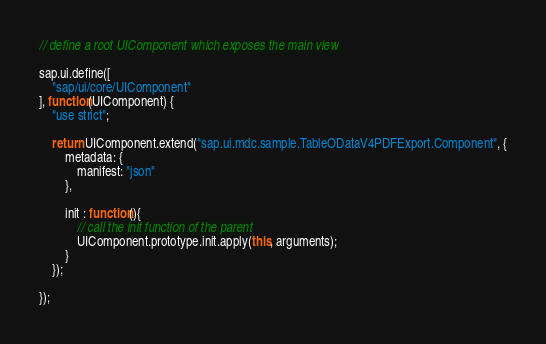Convert code to text. <code><loc_0><loc_0><loc_500><loc_500><_JavaScript_>// define a root UIComponent which exposes the main view

sap.ui.define([
	"sap/ui/core/UIComponent"
], function(UIComponent) {
	"use strict";

	return UIComponent.extend("sap.ui.mdc.sample.TableODataV4PDFExport.Component", {
		metadata: {
			manifest: "json"
		},

		init : function(){
			// call the init function of the parent
			UIComponent.prototype.init.apply(this, arguments);
		}
	});

});</code> 